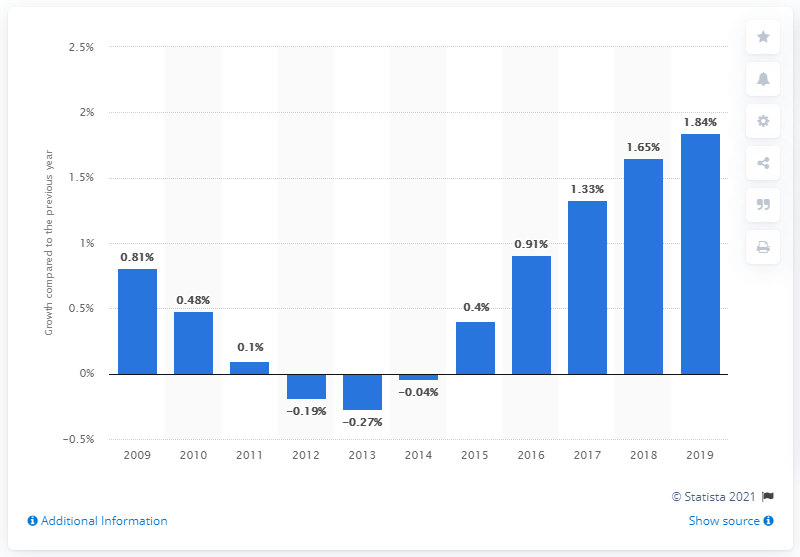Draw attention to some important aspects in this diagram. The population growth in Nepal in 2019 was 1.84%. 